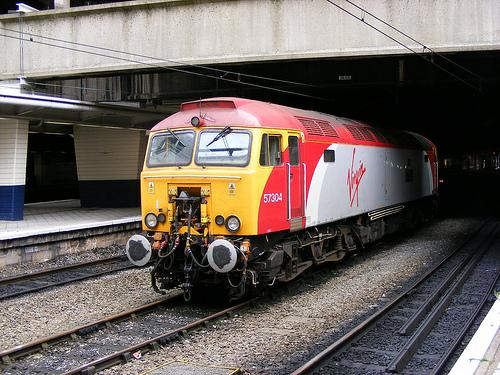Point out the details present on the side of the train. The train has side windows, branding logos, and a yellow portion of the engine, along with visible door and railing to help passengers board. Identify the specific features related to the front of the train. The train has two front windows, headlights, a grey bumper, windshield wipers, and an opening in front with curled tubing. Describe the unique features that can be seen on the roof of the train. The train's roof has ventilation systems and side vents, along with a small light on the top of the engine. Write a sentence about the most significant structure in the scene and its association with the main object. The bridge above the train tracks, with white and blue support beams, towers over a long colorful train that's sitting on the center track. Describe the predominant mode of transportation in the picture and its appearance. A colorful train with various accents and a grey bumper sits on the center track, showcasing features like branding, lights, and a windshield wiper. Mention the primary object in the image along with its colors and features. A red, yellow, and white train with multiple windows, headlights, vents, and a Virgin Mobile logo is emerging from a tunnel on tracks. List any branding visible on the main subject in the picture. A Virgin Mobile logo and the company name "Virgin" in red can be seen on the side of the train. State the key elements describing the location in the image. Train tracks, a platform at a train station, power lines, and a bridge dominate the scene surrounding the colorful train. What is the most noticeable construction element in the given image? A street overpass with wide supporting columns in white and blue can be seen stretching above the train tracks. Spotlight a noteworthy aspect of the image not related directly to the primary object. There are multiple train tracks, including a train track next to a white-tiled walkway and a building adjacent to the train tracks. 